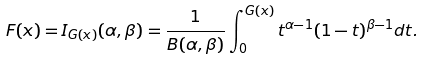<formula> <loc_0><loc_0><loc_500><loc_500>F ( x ) = I _ { G ( x ) } ( \alpha , \beta ) = \frac { 1 } { B ( \alpha , \beta ) } \int _ { 0 } ^ { G ( x ) } t ^ { \alpha - 1 } ( 1 - t ) ^ { \beta - 1 } d t .</formula> 